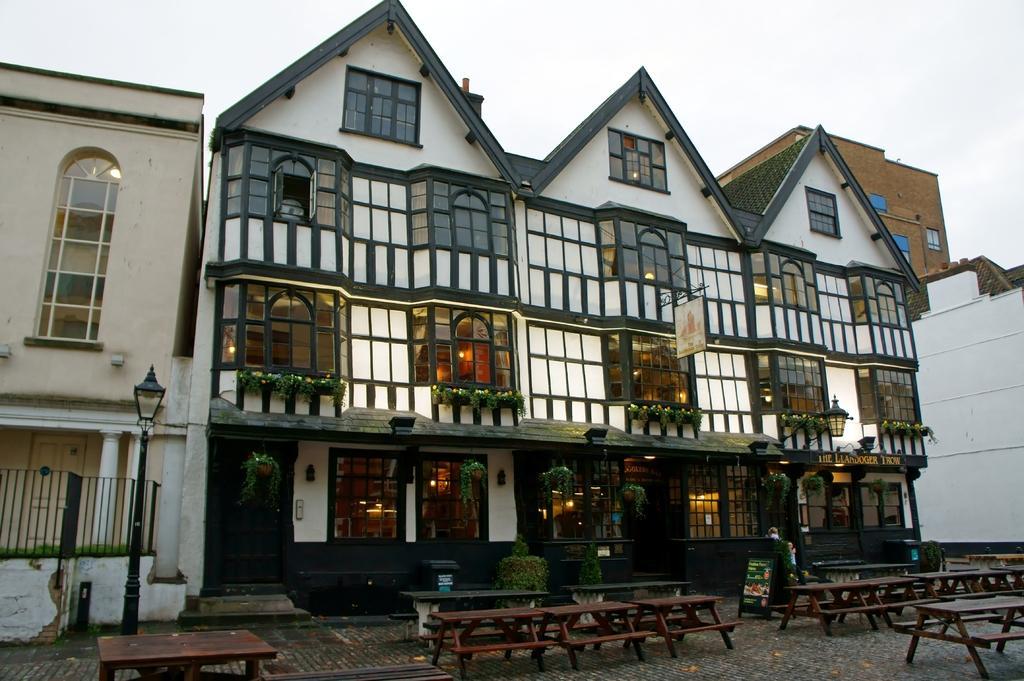Could you give a brief overview of what you see in this image? Here in this picture we can see buildings and houses with number of windows present over a place and in the front we can see number of tables and benches present on the ground and we can also see some plants and bushes present and we can see lamp posts present and we can see the sky is cloudy. 